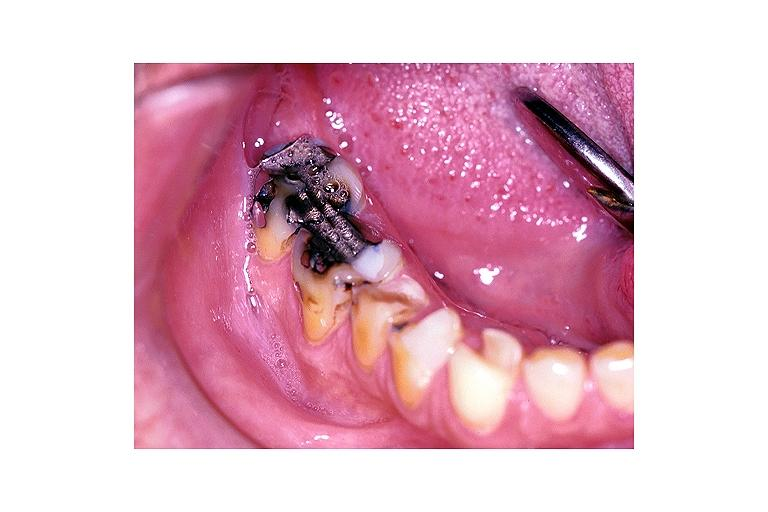what does this image show?
Answer the question using a single word or phrase. Severe abrasion 